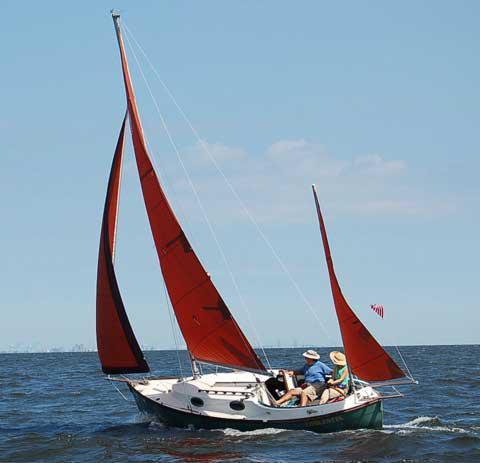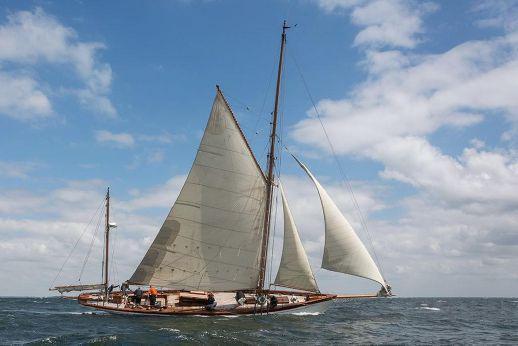The first image is the image on the left, the second image is the image on the right. Considering the images on both sides, is "One boat has more than 3 sails" valid? Answer yes or no. No. The first image is the image on the left, the second image is the image on the right. For the images displayed, is the sentence "the sailboat has no more than 3 sails" factually correct? Answer yes or no. Yes. The first image is the image on the left, the second image is the image on the right. Considering the images on both sides, is "All sailboats have three sails unfurled." valid? Answer yes or no. Yes. The first image is the image on the left, the second image is the image on the right. Evaluate the accuracy of this statement regarding the images: "There is visible land in the background of at least one image.". Is it true? Answer yes or no. No. 